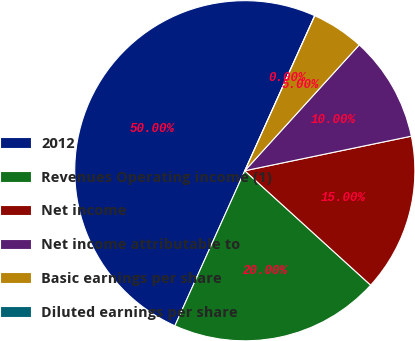Convert chart. <chart><loc_0><loc_0><loc_500><loc_500><pie_chart><fcel>2012<fcel>Revenues Operating income (1)<fcel>Net income<fcel>Net income attributable to<fcel>Basic earnings per share<fcel>Diluted earnings per share<nl><fcel>50.0%<fcel>20.0%<fcel>15.0%<fcel>10.0%<fcel>5.0%<fcel>0.0%<nl></chart> 